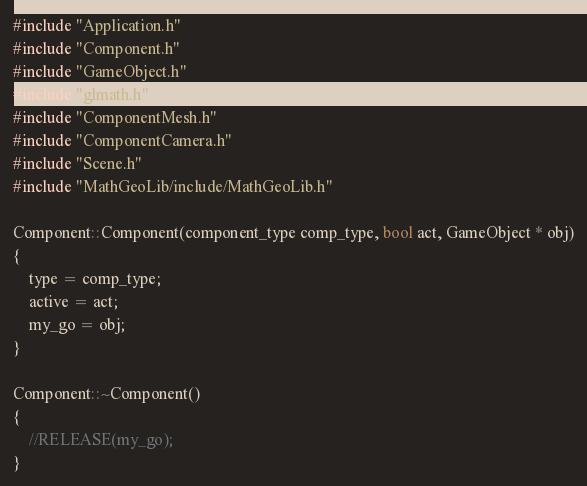Convert code to text. <code><loc_0><loc_0><loc_500><loc_500><_C++_>#include "Application.h"
#include "Component.h"
#include "GameObject.h"
#include "glmath.h"
#include "ComponentMesh.h"
#include "ComponentCamera.h"
#include "Scene.h"
#include "MathGeoLib/include/MathGeoLib.h"

Component::Component(component_type comp_type, bool act, GameObject * obj)
{
	type = comp_type;
	active = act;
	my_go = obj;
}

Component::~Component()
{
	//RELEASE(my_go);
}
</code> 